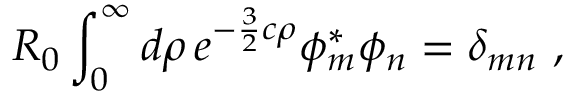<formula> <loc_0><loc_0><loc_500><loc_500>R _ { 0 } \int _ { 0 } ^ { \infty } d \rho \, e ^ { - \frac { 3 } { 2 } c \rho } \phi _ { m } ^ { \ast } \phi _ { n } = \delta _ { m n } ,</formula> 